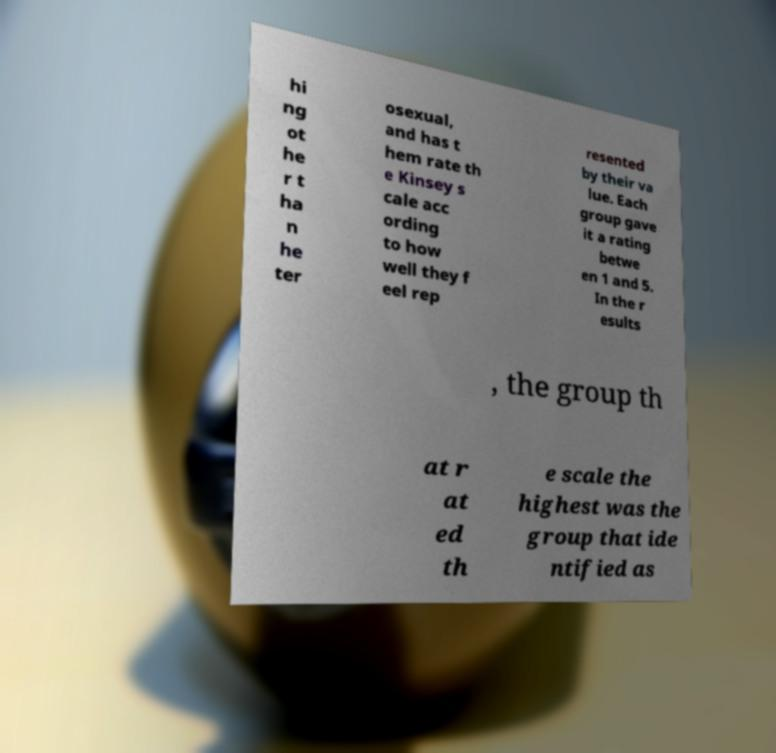Please read and relay the text visible in this image. What does it say? hi ng ot he r t ha n he ter osexual, and has t hem rate th e Kinsey s cale acc ording to how well they f eel rep resented by their va lue. Each group gave it a rating betwe en 1 and 5. In the r esults , the group th at r at ed th e scale the highest was the group that ide ntified as 